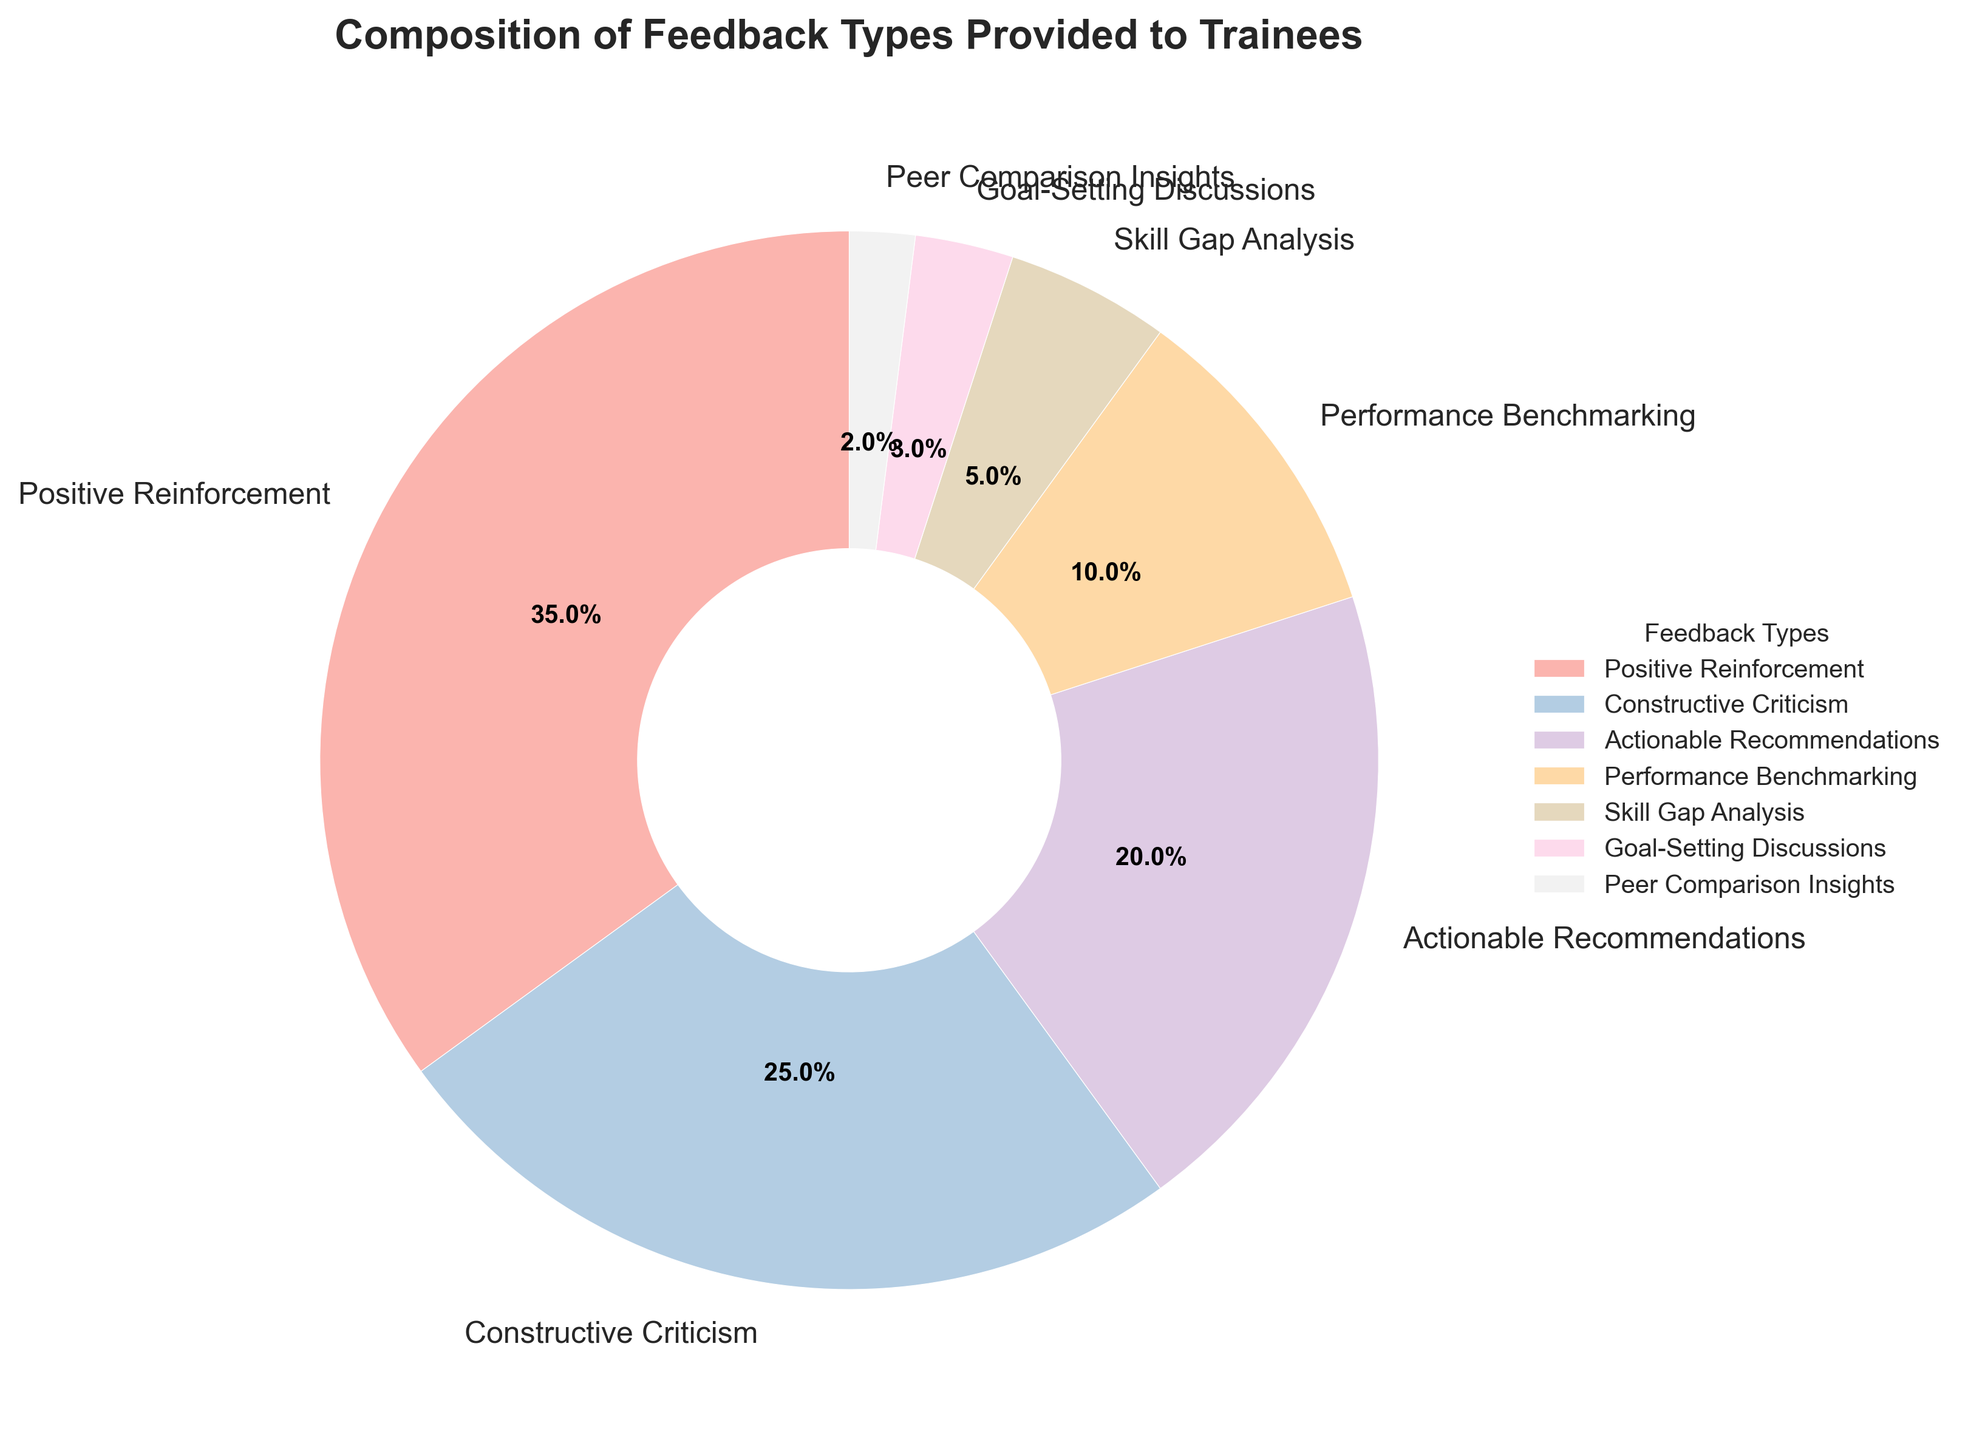Which feedback type is the most frequently provided? According to the pie chart, "Positive Reinforcement" holds the largest section of the pie, representing 35% of the feedback types provided to trainees.
Answer: Positive Reinforcement How much more frequent is "Constructive Criticism" compared to "Peer Comparison Insights"? "Constructive Criticism" accounts for 25% of the feedback, whereas "Peer Comparison Insights" accounts for 2%. Therefore, the difference is 25% - 2% = 23%.
Answer: 23% What percentage of feedback types are related to evaluation or comparison (Performance Benchmarking, Peer Comparison Insights)? Summing up the percentages for "Performance Benchmarking" (10%) and "Peer Comparison Insights" (2%) gives us 10% + 2% = 12%.
Answer: 12% Is the portion of "Actionable Recommendations" larger or smaller than "Skill Gap Analysis"? From the pie chart, "Actionable Recommendations" is 20%, whereas "Skill Gap Analysis" is 5%. Therefore, "Actionable Recommendations" is larger.
Answer: Larger What is the combined percentage of "Goal-Setting Discussions" and "Skill Gap Analysis"? By adding the percentages of "Goal-Setting Discussions" (3%) and "Skill Gap Analysis" (5%), the combined total is 3% + 5% = 8%.
Answer: 8% If you combined "Constructive Criticism", "Performance Benchmarking", and "Goal-Setting Discussions", what would their total percentage be? Adding up the percentages: "Constructive Criticism" (25%), "Performance Benchmarking" (10%), and "Goal-Setting Discussions" (3%) results in 25% + 10% + 3% = 38%.
Answer: 38% Which feedback type occupies the smallest section of the pie chart? According to the chart, "Peer Comparison Insights" occupies the smallest section with 2%.
Answer: Peer Comparison Insights How does the percentage of "Positive Reinforcement" compare to the combined percentage of "Goal-Setting Discussions" and "Peer Comparison Insights"? "Positive Reinforcement" alone is 35%, while the combined percentage of "Goal-Setting Discussions" (3%) and "Peer Comparison Insights" (2%) is 3% + 2% = 5%. 35% is substantially greater than 5%.
Answer: Greater Calculate the average percentage of the feedback types shown in the pie chart. Adding up all the percentages given (35% + 25% + 20% + 10% + 5% + 3% + 2% = 100%), the average percentage is 100% / 7 ≈ 14.29%.
Answer: 14.29% Is the section for "Skill Gap Analysis" closer in size to "Actionable Recommendations" or "Performance Benchmarking"? "Skill Gap Analysis" accounts for 5%. "Actionable Recommendations" is 20%, which is a difference of 15%, whereas "Performance Benchmarking" is 10%, a difference of 5%. Thus, it is closer to "Performance Benchmarking".
Answer: Performance Benchmarking 